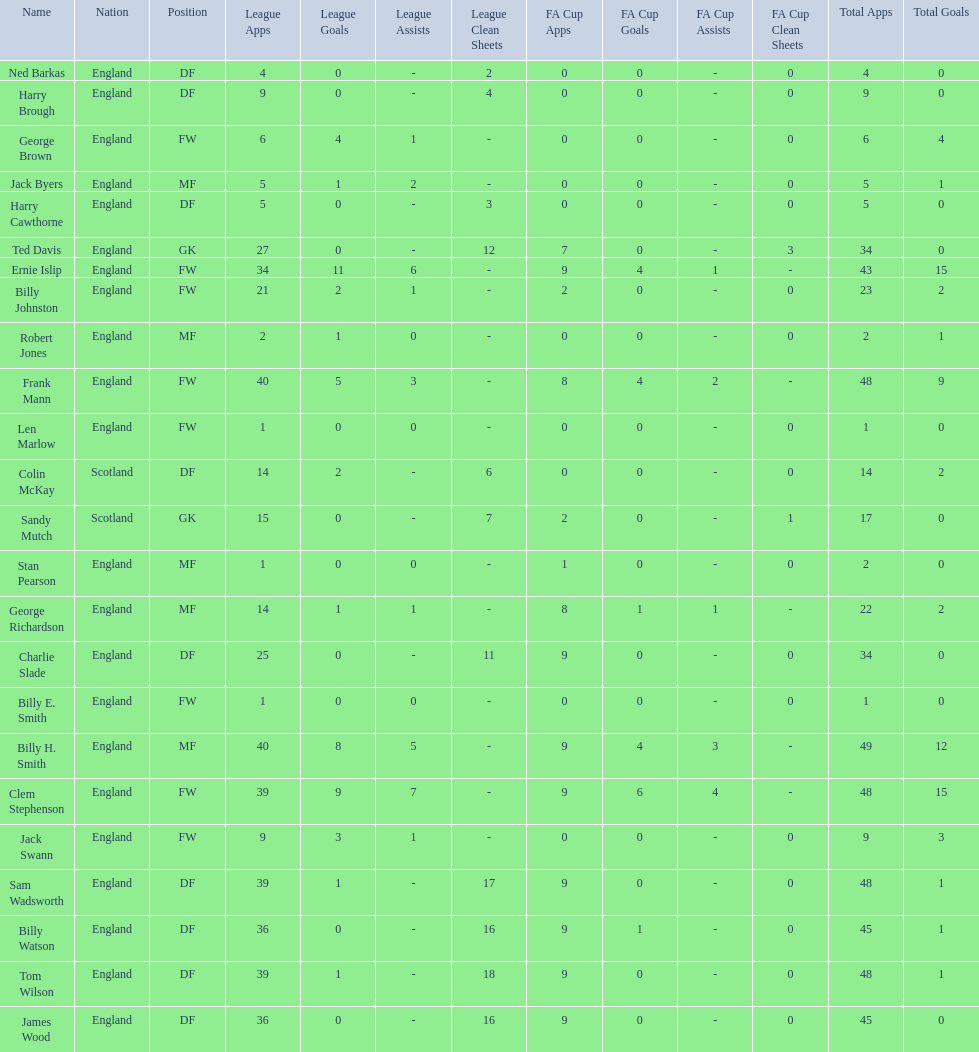What is the first name listed? Ned Barkas. 